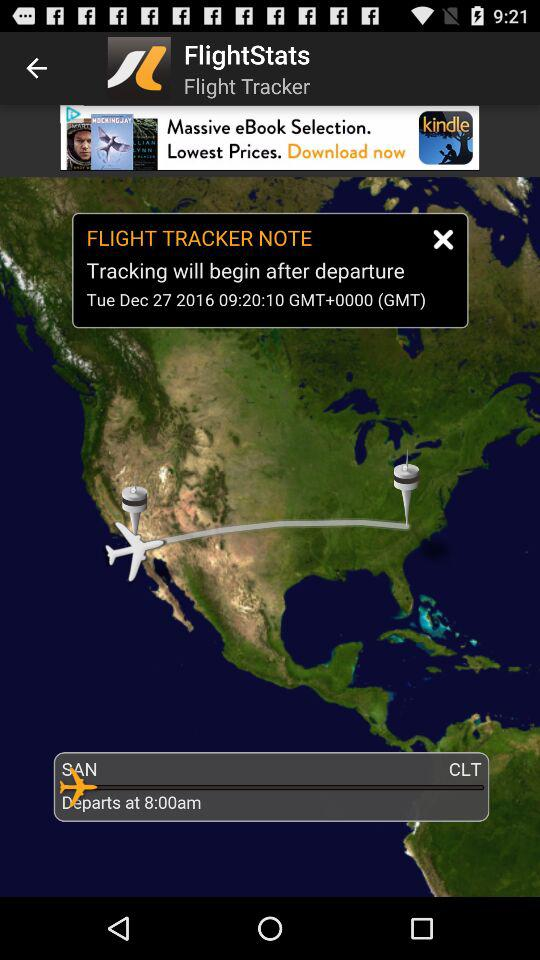What is the name of the application? The name of the application is "FlightStats". 